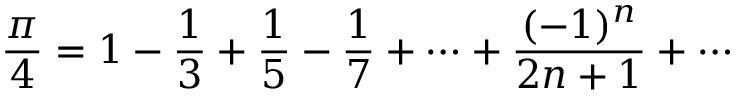Convert formula to latex. <formula><loc_0><loc_0><loc_500><loc_500>{ \frac { \pi } { 4 } } = 1 - { \frac { 1 } { 3 } } + { \frac { 1 } { 5 } } - { \frac { 1 } { 7 } } + \cdots + { \frac { ( - 1 ) ^ { n } } { 2 n + 1 } } + \cdots</formula> 